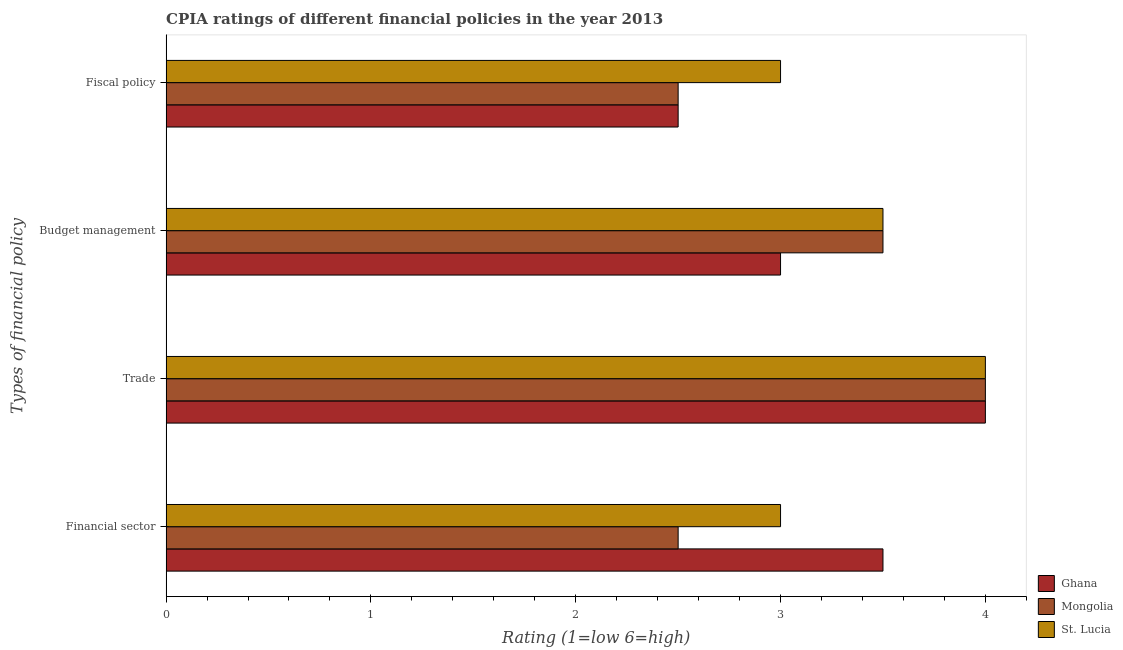How many different coloured bars are there?
Keep it short and to the point. 3. Are the number of bars on each tick of the Y-axis equal?
Ensure brevity in your answer.  Yes. How many bars are there on the 1st tick from the top?
Keep it short and to the point. 3. What is the label of the 3rd group of bars from the top?
Your answer should be compact. Trade. What is the cpia rating of financial sector in St. Lucia?
Keep it short and to the point. 3. Across all countries, what is the maximum cpia rating of financial sector?
Ensure brevity in your answer.  3.5. Across all countries, what is the minimum cpia rating of financial sector?
Ensure brevity in your answer.  2.5. In which country was the cpia rating of budget management maximum?
Offer a very short reply. Mongolia. What is the total cpia rating of trade in the graph?
Offer a terse response. 12. What is the average cpia rating of budget management per country?
Offer a terse response. 3.33. In how many countries, is the cpia rating of trade greater than 3.6 ?
Your answer should be compact. 3. What is the ratio of the cpia rating of fiscal policy in Ghana to that in St. Lucia?
Give a very brief answer. 0.83. In how many countries, is the cpia rating of fiscal policy greater than the average cpia rating of fiscal policy taken over all countries?
Your response must be concise. 1. Is the sum of the cpia rating of fiscal policy in Mongolia and St. Lucia greater than the maximum cpia rating of financial sector across all countries?
Give a very brief answer. Yes. What does the 1st bar from the top in Financial sector represents?
Offer a very short reply. St. Lucia. What does the 2nd bar from the bottom in Budget management represents?
Keep it short and to the point. Mongolia. Are all the bars in the graph horizontal?
Keep it short and to the point. Yes. What is the difference between two consecutive major ticks on the X-axis?
Keep it short and to the point. 1. Are the values on the major ticks of X-axis written in scientific E-notation?
Give a very brief answer. No. How many legend labels are there?
Your answer should be compact. 3. What is the title of the graph?
Your response must be concise. CPIA ratings of different financial policies in the year 2013. Does "Heavily indebted poor countries" appear as one of the legend labels in the graph?
Your answer should be very brief. No. What is the label or title of the Y-axis?
Give a very brief answer. Types of financial policy. What is the Rating (1=low 6=high) in St. Lucia in Financial sector?
Offer a very short reply. 3. What is the Rating (1=low 6=high) in Ghana in Trade?
Your response must be concise. 4. What is the Rating (1=low 6=high) of St. Lucia in Trade?
Provide a short and direct response. 4. What is the Rating (1=low 6=high) of Mongolia in Budget management?
Provide a succinct answer. 3.5. What is the Rating (1=low 6=high) of Ghana in Fiscal policy?
Provide a short and direct response. 2.5. What is the Rating (1=low 6=high) of Mongolia in Fiscal policy?
Provide a short and direct response. 2.5. What is the Rating (1=low 6=high) of St. Lucia in Fiscal policy?
Provide a short and direct response. 3. Across all Types of financial policy, what is the maximum Rating (1=low 6=high) in Ghana?
Offer a very short reply. 4. Across all Types of financial policy, what is the minimum Rating (1=low 6=high) of Ghana?
Provide a succinct answer. 2.5. What is the total Rating (1=low 6=high) in Ghana in the graph?
Ensure brevity in your answer.  13. What is the total Rating (1=low 6=high) of Mongolia in the graph?
Give a very brief answer. 12.5. What is the difference between the Rating (1=low 6=high) of Ghana in Financial sector and that in Trade?
Provide a succinct answer. -0.5. What is the difference between the Rating (1=low 6=high) of Mongolia in Financial sector and that in Trade?
Offer a terse response. -1.5. What is the difference between the Rating (1=low 6=high) of St. Lucia in Financial sector and that in Trade?
Ensure brevity in your answer.  -1. What is the difference between the Rating (1=low 6=high) of Mongolia in Financial sector and that in Fiscal policy?
Ensure brevity in your answer.  0. What is the difference between the Rating (1=low 6=high) in St. Lucia in Financial sector and that in Fiscal policy?
Your response must be concise. 0. What is the difference between the Rating (1=low 6=high) in Mongolia in Trade and that in Fiscal policy?
Keep it short and to the point. 1.5. What is the difference between the Rating (1=low 6=high) in St. Lucia in Budget management and that in Fiscal policy?
Keep it short and to the point. 0.5. What is the difference between the Rating (1=low 6=high) in Ghana in Financial sector and the Rating (1=low 6=high) in St. Lucia in Trade?
Keep it short and to the point. -0.5. What is the difference between the Rating (1=low 6=high) in Mongolia in Financial sector and the Rating (1=low 6=high) in St. Lucia in Trade?
Your answer should be compact. -1.5. What is the difference between the Rating (1=low 6=high) in Ghana in Financial sector and the Rating (1=low 6=high) in Mongolia in Fiscal policy?
Your response must be concise. 1. What is the difference between the Rating (1=low 6=high) in Ghana in Financial sector and the Rating (1=low 6=high) in St. Lucia in Fiscal policy?
Provide a succinct answer. 0.5. What is the difference between the Rating (1=low 6=high) in Mongolia in Financial sector and the Rating (1=low 6=high) in St. Lucia in Fiscal policy?
Keep it short and to the point. -0.5. What is the difference between the Rating (1=low 6=high) in Ghana in Trade and the Rating (1=low 6=high) in Mongolia in Budget management?
Ensure brevity in your answer.  0.5. What is the difference between the Rating (1=low 6=high) of Mongolia in Trade and the Rating (1=low 6=high) of St. Lucia in Budget management?
Your response must be concise. 0.5. What is the difference between the Rating (1=low 6=high) in Ghana in Trade and the Rating (1=low 6=high) in St. Lucia in Fiscal policy?
Keep it short and to the point. 1. What is the difference between the Rating (1=low 6=high) of Mongolia in Trade and the Rating (1=low 6=high) of St. Lucia in Fiscal policy?
Provide a succinct answer. 1. What is the difference between the Rating (1=low 6=high) in Ghana in Budget management and the Rating (1=low 6=high) in Mongolia in Fiscal policy?
Provide a short and direct response. 0.5. What is the difference between the Rating (1=low 6=high) of Ghana in Budget management and the Rating (1=low 6=high) of St. Lucia in Fiscal policy?
Provide a short and direct response. 0. What is the difference between the Rating (1=low 6=high) in Mongolia in Budget management and the Rating (1=low 6=high) in St. Lucia in Fiscal policy?
Provide a short and direct response. 0.5. What is the average Rating (1=low 6=high) of Ghana per Types of financial policy?
Provide a short and direct response. 3.25. What is the average Rating (1=low 6=high) in Mongolia per Types of financial policy?
Your response must be concise. 3.12. What is the average Rating (1=low 6=high) of St. Lucia per Types of financial policy?
Give a very brief answer. 3.38. What is the difference between the Rating (1=low 6=high) in Ghana and Rating (1=low 6=high) in St. Lucia in Financial sector?
Ensure brevity in your answer.  0.5. What is the difference between the Rating (1=low 6=high) in Mongolia and Rating (1=low 6=high) in St. Lucia in Trade?
Provide a short and direct response. 0. What is the difference between the Rating (1=low 6=high) of Ghana and Rating (1=low 6=high) of St. Lucia in Budget management?
Provide a succinct answer. -0.5. What is the difference between the Rating (1=low 6=high) of Ghana and Rating (1=low 6=high) of St. Lucia in Fiscal policy?
Give a very brief answer. -0.5. What is the ratio of the Rating (1=low 6=high) in Mongolia in Financial sector to that in Trade?
Your answer should be very brief. 0.62. What is the ratio of the Rating (1=low 6=high) in St. Lucia in Financial sector to that in Trade?
Offer a terse response. 0.75. What is the ratio of the Rating (1=low 6=high) in Ghana in Financial sector to that in Budget management?
Your answer should be very brief. 1.17. What is the ratio of the Rating (1=low 6=high) in Mongolia in Financial sector to that in Budget management?
Offer a terse response. 0.71. What is the ratio of the Rating (1=low 6=high) of Ghana in Trade to that in Budget management?
Your answer should be very brief. 1.33. What is the ratio of the Rating (1=low 6=high) in Mongolia in Trade to that in Budget management?
Your answer should be very brief. 1.14. What is the ratio of the Rating (1=low 6=high) in Mongolia in Trade to that in Fiscal policy?
Provide a short and direct response. 1.6. What is the ratio of the Rating (1=low 6=high) in St. Lucia in Trade to that in Fiscal policy?
Offer a terse response. 1.33. What is the ratio of the Rating (1=low 6=high) in Ghana in Budget management to that in Fiscal policy?
Provide a short and direct response. 1.2. What is the ratio of the Rating (1=low 6=high) in Mongolia in Budget management to that in Fiscal policy?
Provide a succinct answer. 1.4. What is the ratio of the Rating (1=low 6=high) of St. Lucia in Budget management to that in Fiscal policy?
Give a very brief answer. 1.17. What is the difference between the highest and the second highest Rating (1=low 6=high) of Ghana?
Provide a short and direct response. 0.5. What is the difference between the highest and the second highest Rating (1=low 6=high) of Mongolia?
Your response must be concise. 0.5. What is the difference between the highest and the second highest Rating (1=low 6=high) in St. Lucia?
Offer a very short reply. 0.5. What is the difference between the highest and the lowest Rating (1=low 6=high) in Mongolia?
Offer a terse response. 1.5. What is the difference between the highest and the lowest Rating (1=low 6=high) of St. Lucia?
Keep it short and to the point. 1. 